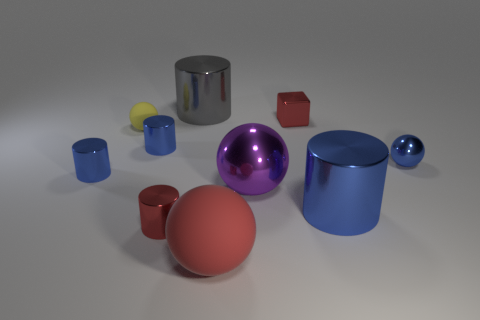What number of metal cylinders are the same color as the small metal block?
Keep it short and to the point. 1. What is the size of the blue shiny cylinder that is on the left side of the big blue shiny object and in front of the small shiny ball?
Ensure brevity in your answer.  Small. Are there fewer red things that are behind the small red cylinder than gray cylinders?
Give a very brief answer. No. Is the material of the purple sphere the same as the yellow object?
Ensure brevity in your answer.  No. How many things are either metallic cylinders or blue spheres?
Provide a succinct answer. 6. How many cylinders are the same material as the red block?
Your response must be concise. 5. There is a yellow rubber object that is the same shape as the purple object; what size is it?
Your answer should be compact. Small. Are there any big purple metal balls behind the red shiny block?
Your response must be concise. No. What material is the gray object?
Your answer should be compact. Metal. There is a matte object behind the large matte object; is its color the same as the block?
Ensure brevity in your answer.  No. 